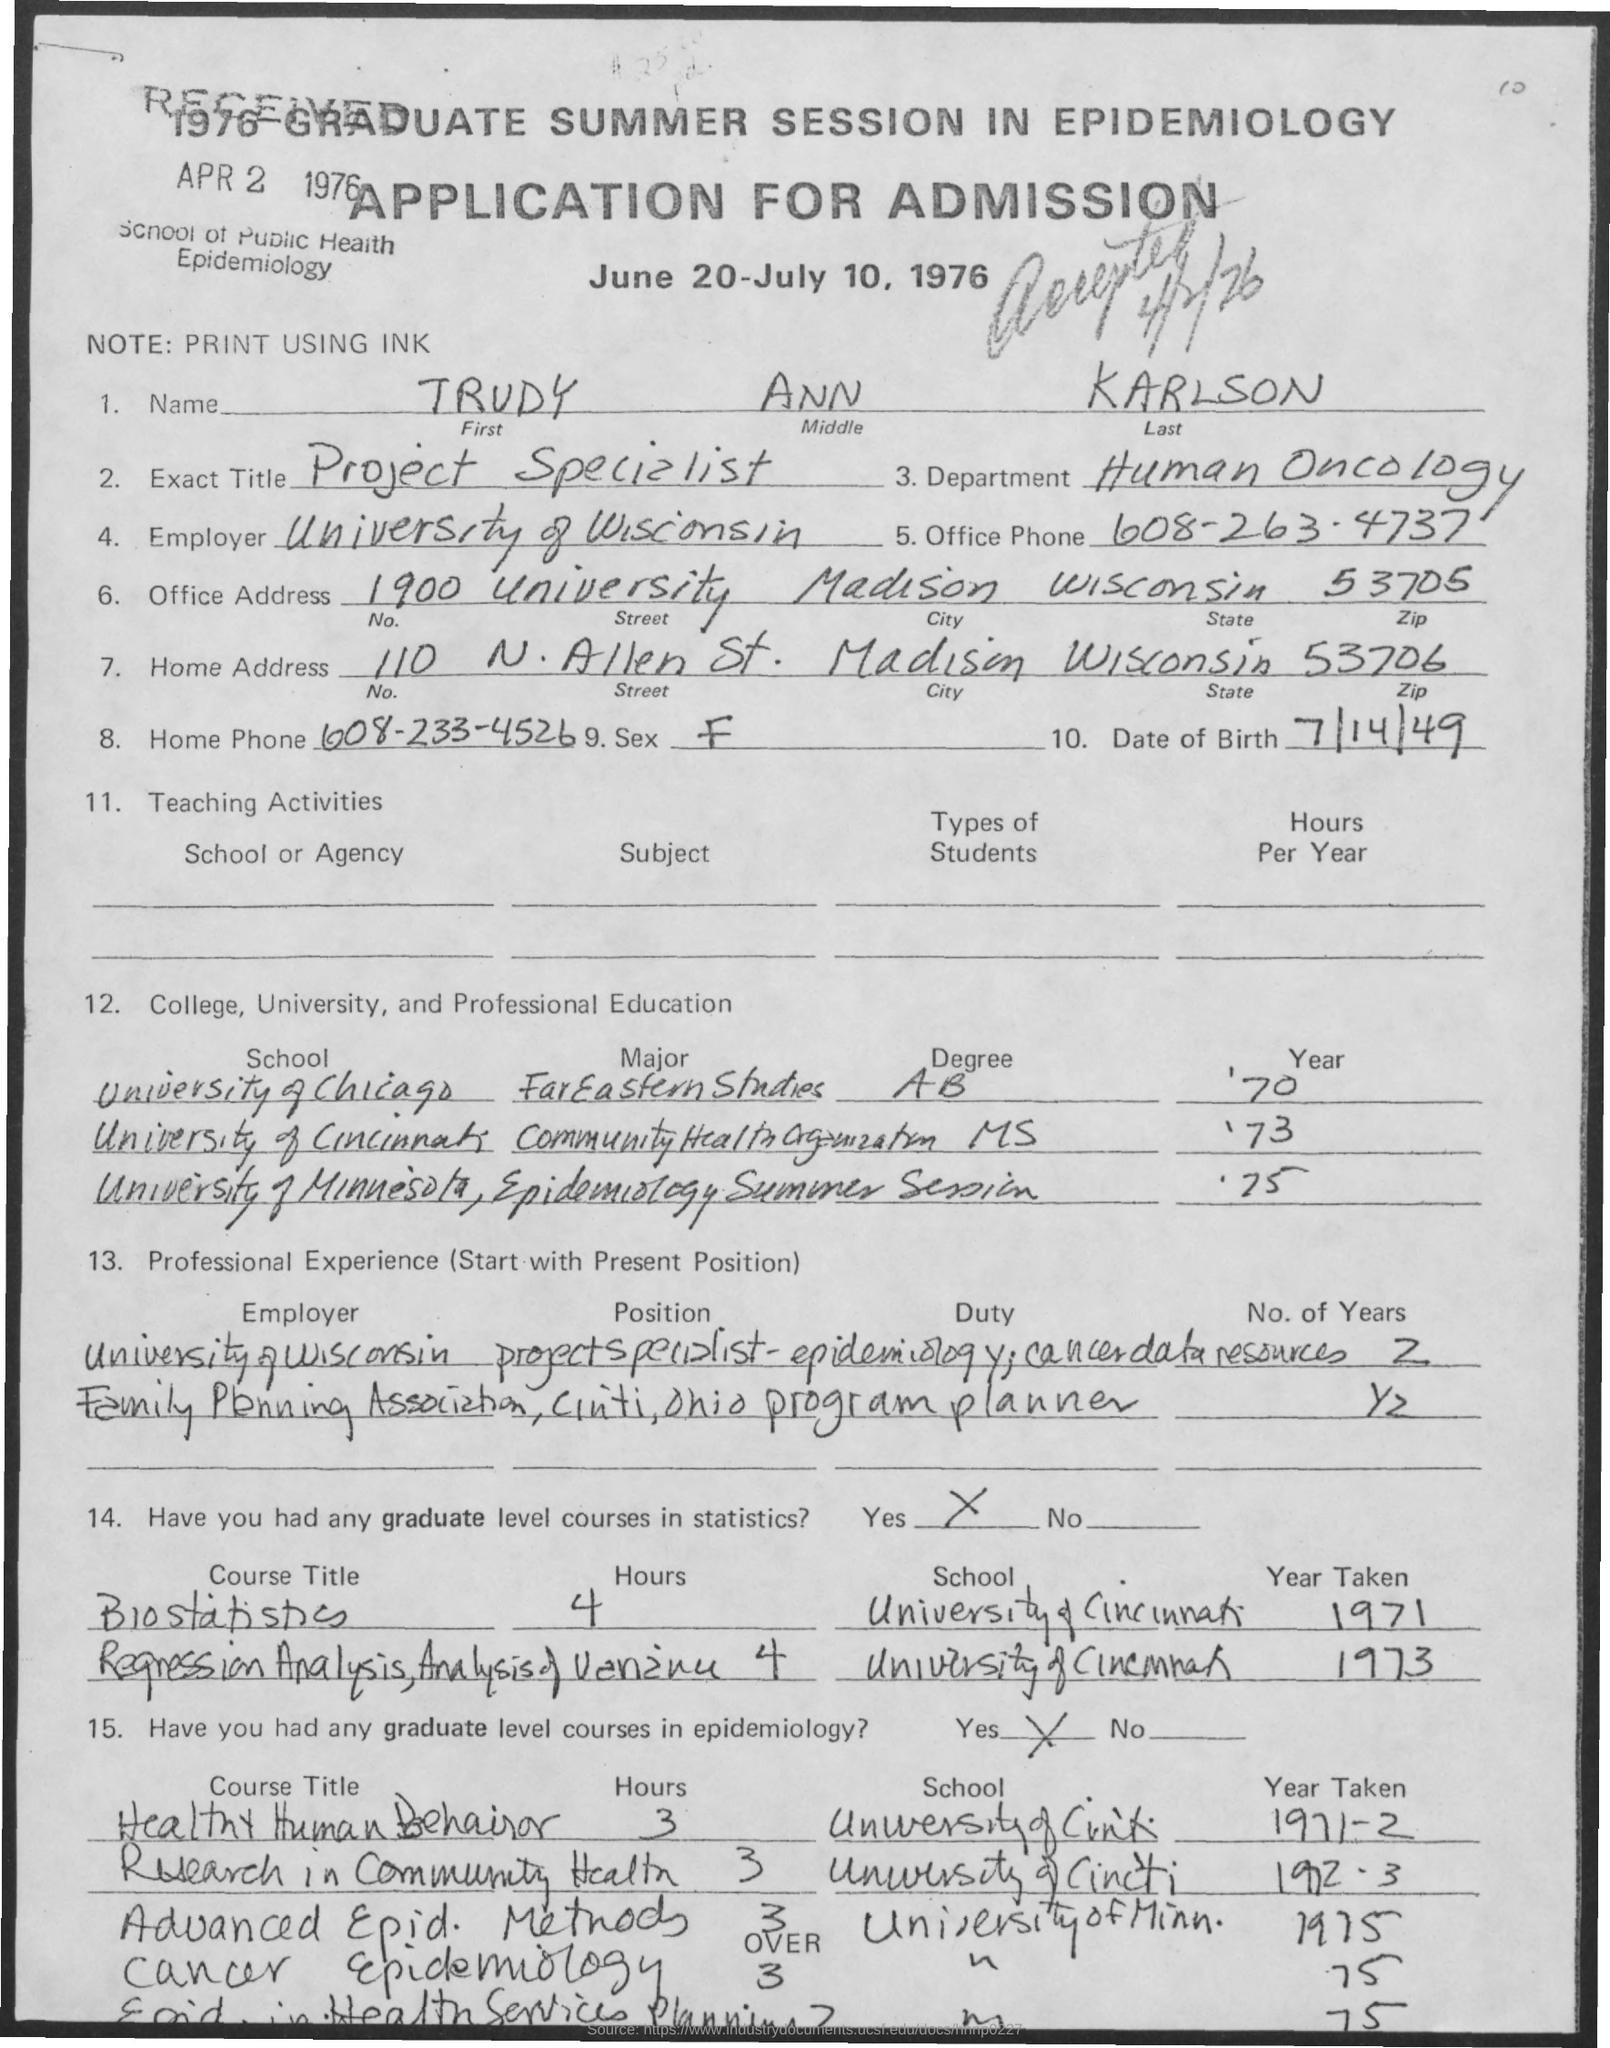Highlight a few significant elements in this photo. The zip code that was not mentioned in the office address is 53705. The exact title of Trudy Ann Karlson is "Project Specialist. The last name of the applicant is Karlson. Trudy Ann Karlson is employed in the department of human oncology. The office phone number mentioned in the application is 608-263-4737. 